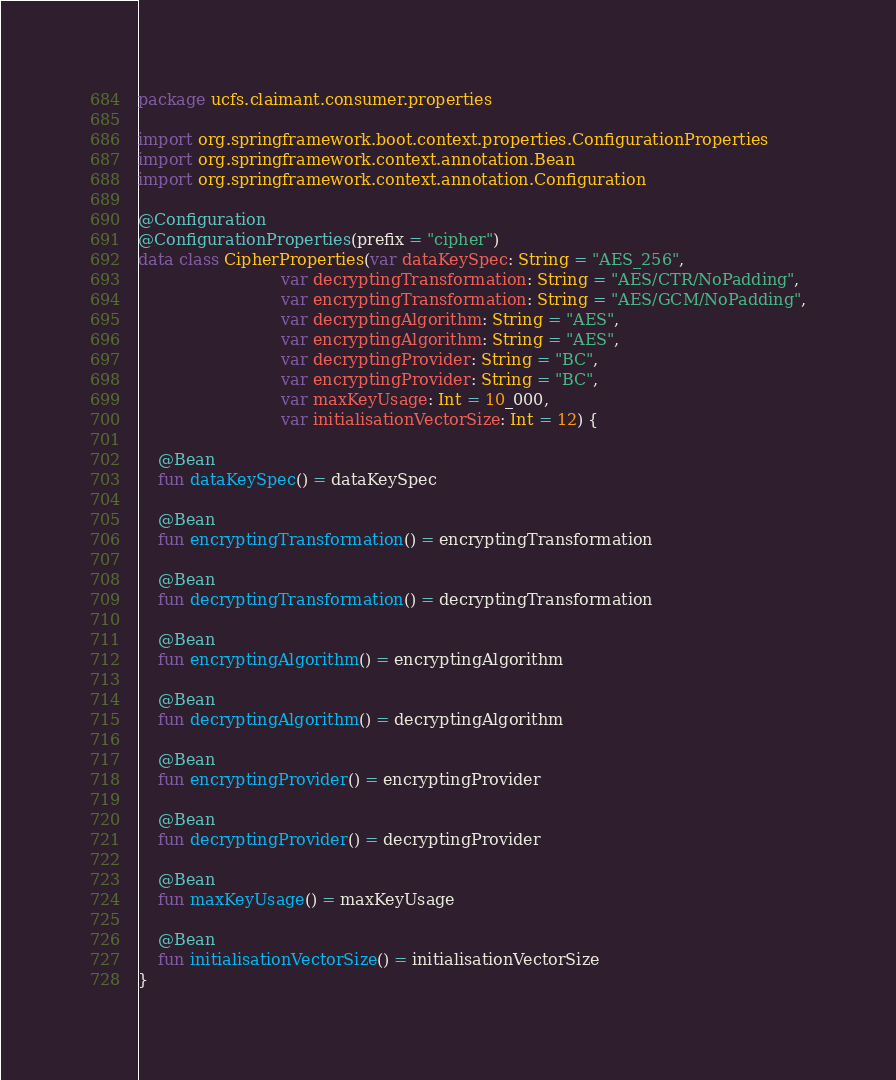<code> <loc_0><loc_0><loc_500><loc_500><_Kotlin_>package ucfs.claimant.consumer.properties

import org.springframework.boot.context.properties.ConfigurationProperties
import org.springframework.context.annotation.Bean
import org.springframework.context.annotation.Configuration

@Configuration
@ConfigurationProperties(prefix = "cipher")
data class CipherProperties(var dataKeySpec: String = "AES_256",
                            var decryptingTransformation: String = "AES/CTR/NoPadding",
                            var encryptingTransformation: String = "AES/GCM/NoPadding",
                            var decryptingAlgorithm: String = "AES",
                            var encryptingAlgorithm: String = "AES",
                            var decryptingProvider: String = "BC",
                            var encryptingProvider: String = "BC",
                            var maxKeyUsage: Int = 10_000,
                            var initialisationVectorSize: Int = 12) {

    @Bean
    fun dataKeySpec() = dataKeySpec

    @Bean
    fun encryptingTransformation() = encryptingTransformation

    @Bean
    fun decryptingTransformation() = decryptingTransformation

    @Bean
    fun encryptingAlgorithm() = encryptingAlgorithm

    @Bean
    fun decryptingAlgorithm() = decryptingAlgorithm

    @Bean
    fun encryptingProvider() = encryptingProvider

    @Bean
    fun decryptingProvider() = decryptingProvider

    @Bean
    fun maxKeyUsage() = maxKeyUsage

    @Bean
    fun initialisationVectorSize() = initialisationVectorSize
}
</code> 